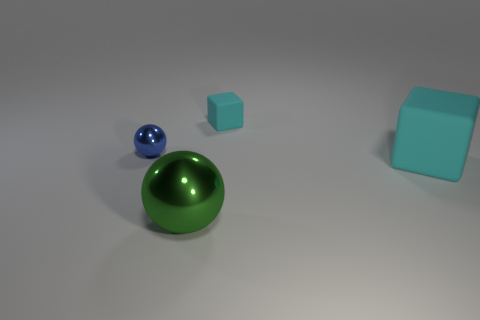Add 2 small purple metallic cubes. How many objects exist? 6 Add 4 cyan cubes. How many cyan cubes are left? 6 Add 1 big blue matte cubes. How many big blue matte cubes exist? 1 Subtract 0 gray blocks. How many objects are left? 4 Subtract all big rubber things. Subtract all small yellow metal cylinders. How many objects are left? 3 